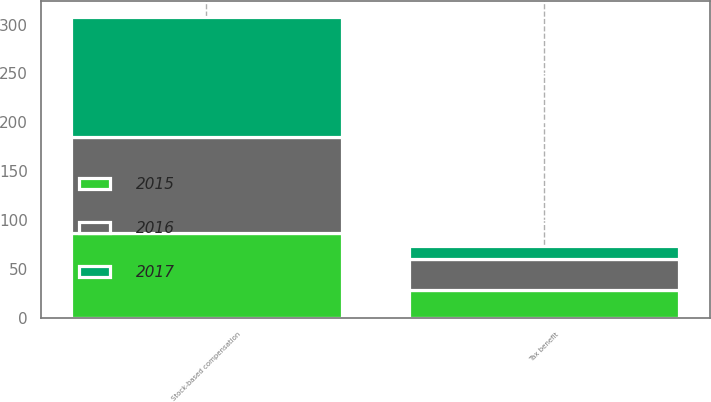Convert chart. <chart><loc_0><loc_0><loc_500><loc_500><stacked_bar_chart><ecel><fcel>Stock-based compensation<fcel>Tax benefit<nl><fcel>2017<fcel>122.9<fcel>13.3<nl><fcel>2016<fcel>98.1<fcel>31.9<nl><fcel>2015<fcel>87.2<fcel>28.6<nl></chart> 